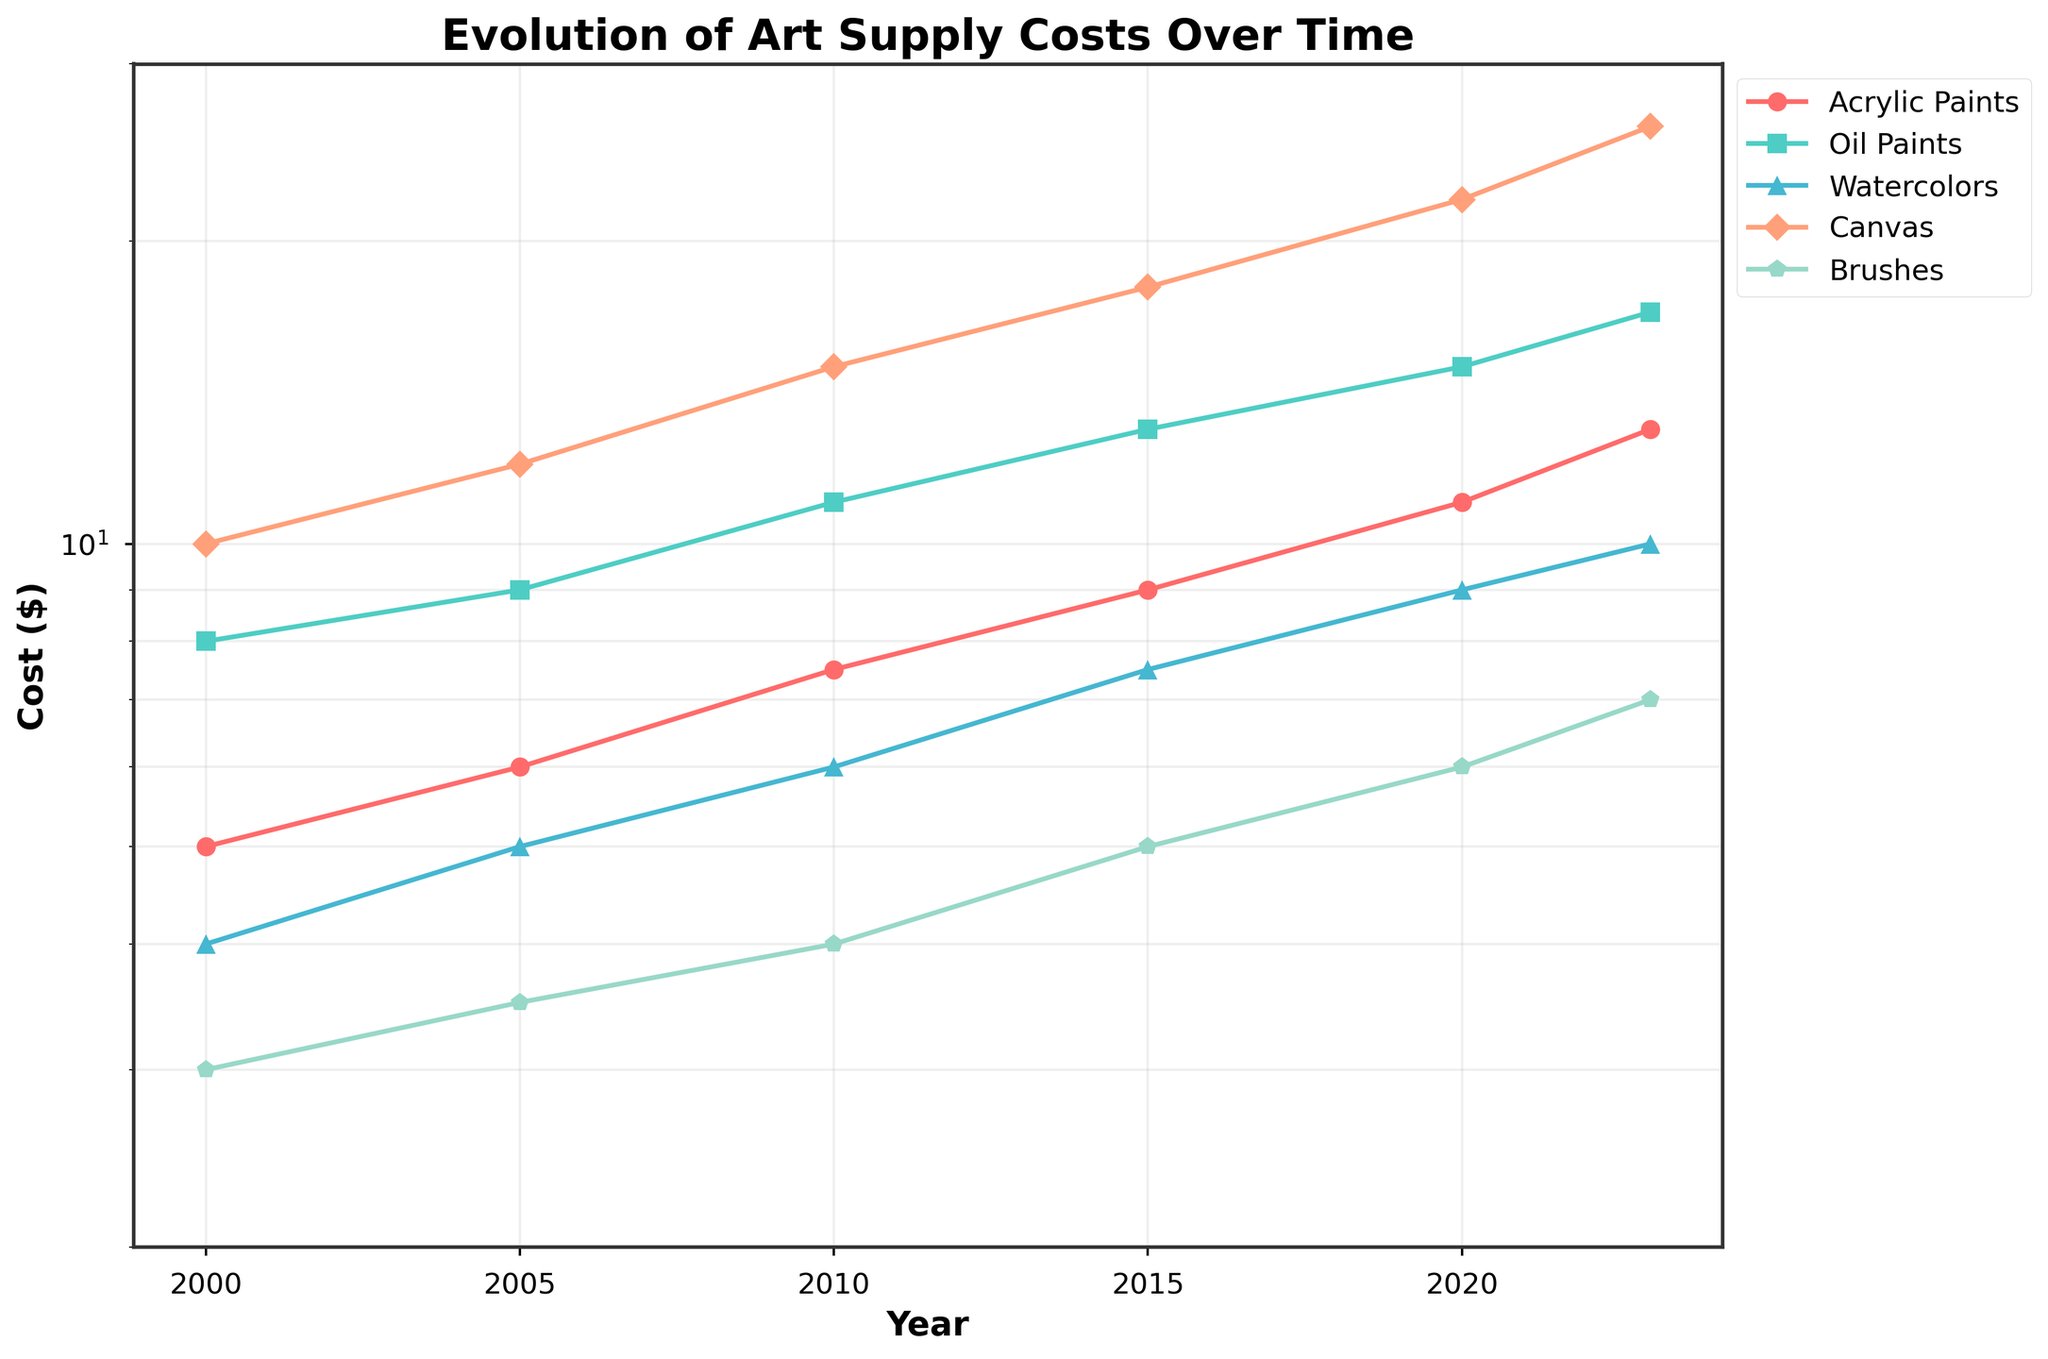What is the title of the plot? The title is generally displayed at the top of the plot. In this figure, it's clearly mentioned at the center of the top.
Answer: Evolution of Art Supply Costs Over Time What are the different types of art supplies tracked in this figure? The legend on the right side of the plot lists the different types of art supplies being tracked with their corresponding colors and markers.
Answer: Acrylic Paints, Oil Paints, Watercolors, Canvas, Brushes Between which two years did the cost of watercolors experience the highest increase? By examining the steepness of the lines representing watercolors between consecutive years, we can determine the highest increase. The line between 2010 and 2015 shows the most significant jump.
Answer: 2010 and 2015 Which art supply showed the least cost growth between 2000 and 2023? By comparing the slopes of the lines representing each art supply from 2000 to 2023, the art supply with the flattest line will have the least growth. Brushes have the smallest slope indicating the least growth.
Answer: Brushes What is the cost of Canvas in 2020? By looking at the point labelled for the year 2020 on the Canvas line, we find the value. The point meets the y-axis at 22.
Answer: $22 How has the cost of Acrylic Paints changed from 2000 to 2023? We can compare the y-values of the Acrylic Paints line at the years 2000 and 2023 from the plot. In 2000 it was $5 and in 2023 it is $13.
Answer: Increased from $5 to $13 Which art supply had the highest cost in 2015? We look at the y-values of all the art supplies in the year 2015; Canvas is at $18, which is the highest.
Answer: Canvas Between which two years did the cost of Oil Paints experience the smallest increase? Check the segments of the Oil Paints line that are closest to flat. The least steep segment is between 2000 and 2005.
Answer: 2000 and 2005 What is the combined cost of Brushes and Watercolors in 2023? Look at the y-values for Brushes and Watercolors in 2023. Brushes are at $7, and Watercolors are at $10. Adding them together, we get 7 + 10.
Answer: $17 Is the trend of Canvas costs linear or exponential from 2000 to 2023? Since the plot has a logarithmic y-axis, a linear trend in a logarithmic scale indicates an exponential growth. The Canvas line shows a straight, linear rising trend indicating exponential growth in real terms.
Answer: Exponential 